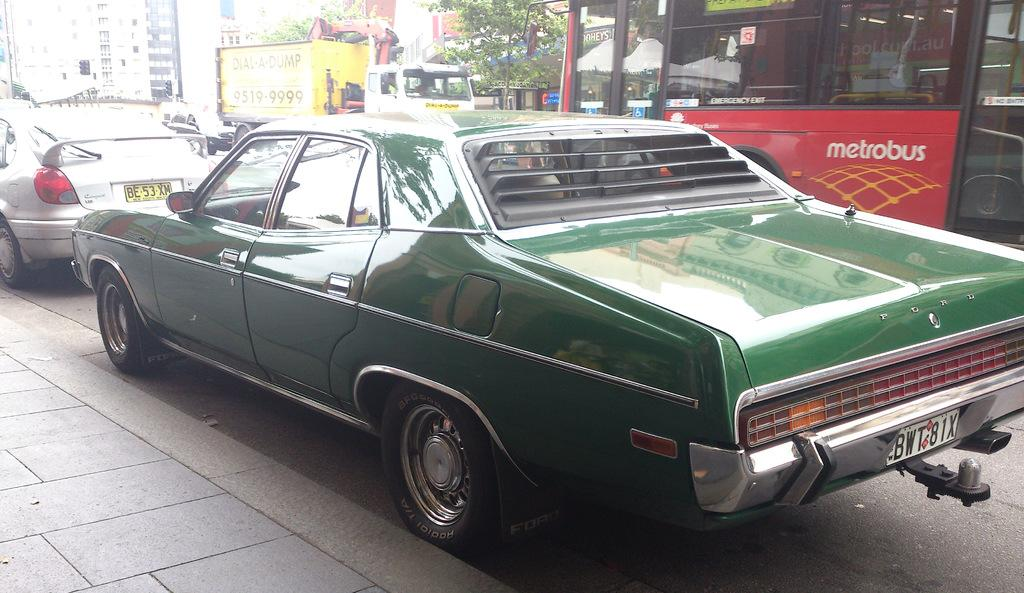What is the main subject of the image? There is a car on the road in the image. What else can be seen in the image besides the car? There are vehicles and trees visible in the background of the image. What type of structures are present in the background? There are buildings in the background of the image. What type of cap is the zebra wearing in the image? There is no zebra or cap present in the image. How is the waste being managed in the image? There is no mention of waste in the image, as it focuses on the car, vehicles, trees, and buildings in the background. 